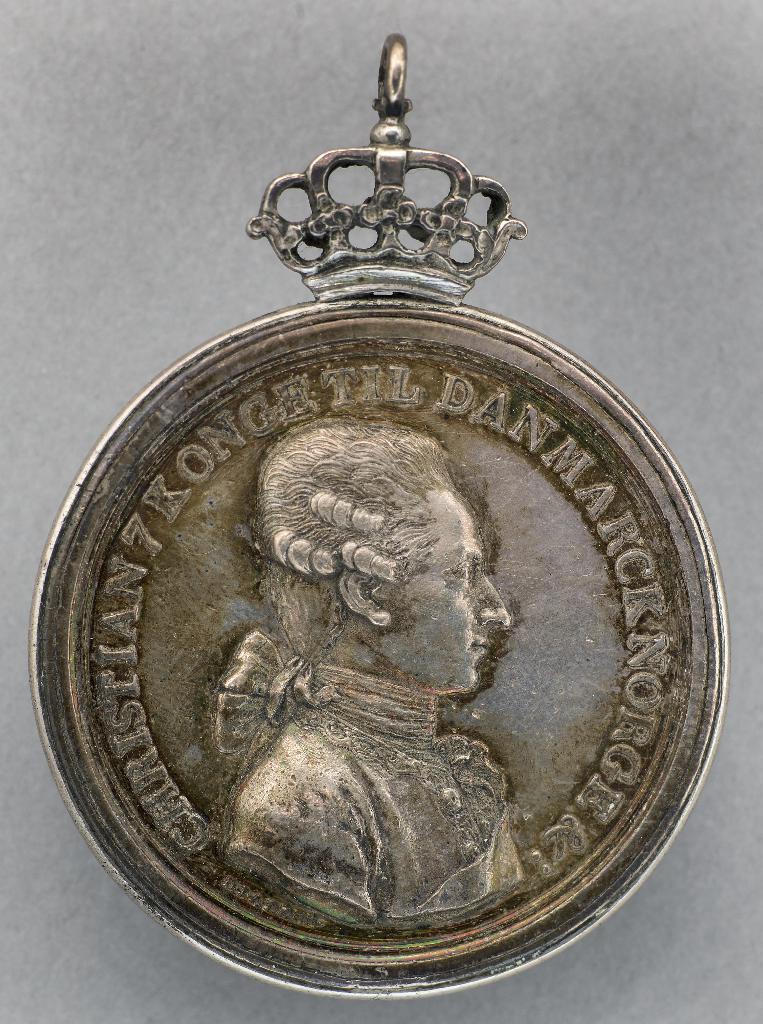Can you describe this image briefly? In this image there is a locket. On the locket there is an engraving of a sculpture. 